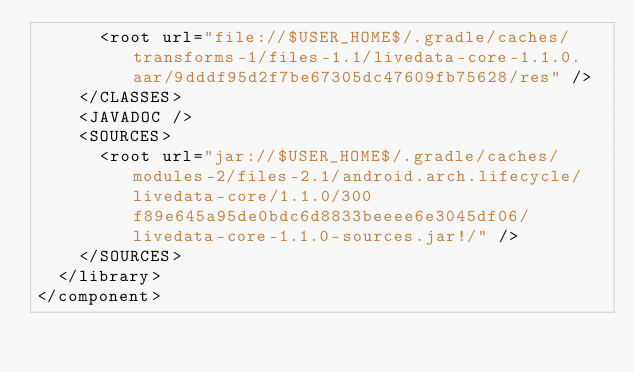<code> <loc_0><loc_0><loc_500><loc_500><_XML_>      <root url="file://$USER_HOME$/.gradle/caches/transforms-1/files-1.1/livedata-core-1.1.0.aar/9dddf95d2f7be67305dc47609fb75628/res" />
    </CLASSES>
    <JAVADOC />
    <SOURCES>
      <root url="jar://$USER_HOME$/.gradle/caches/modules-2/files-2.1/android.arch.lifecycle/livedata-core/1.1.0/300f89e645a95de0bdc6d8833beeee6e3045df06/livedata-core-1.1.0-sources.jar!/" />
    </SOURCES>
  </library>
</component></code> 